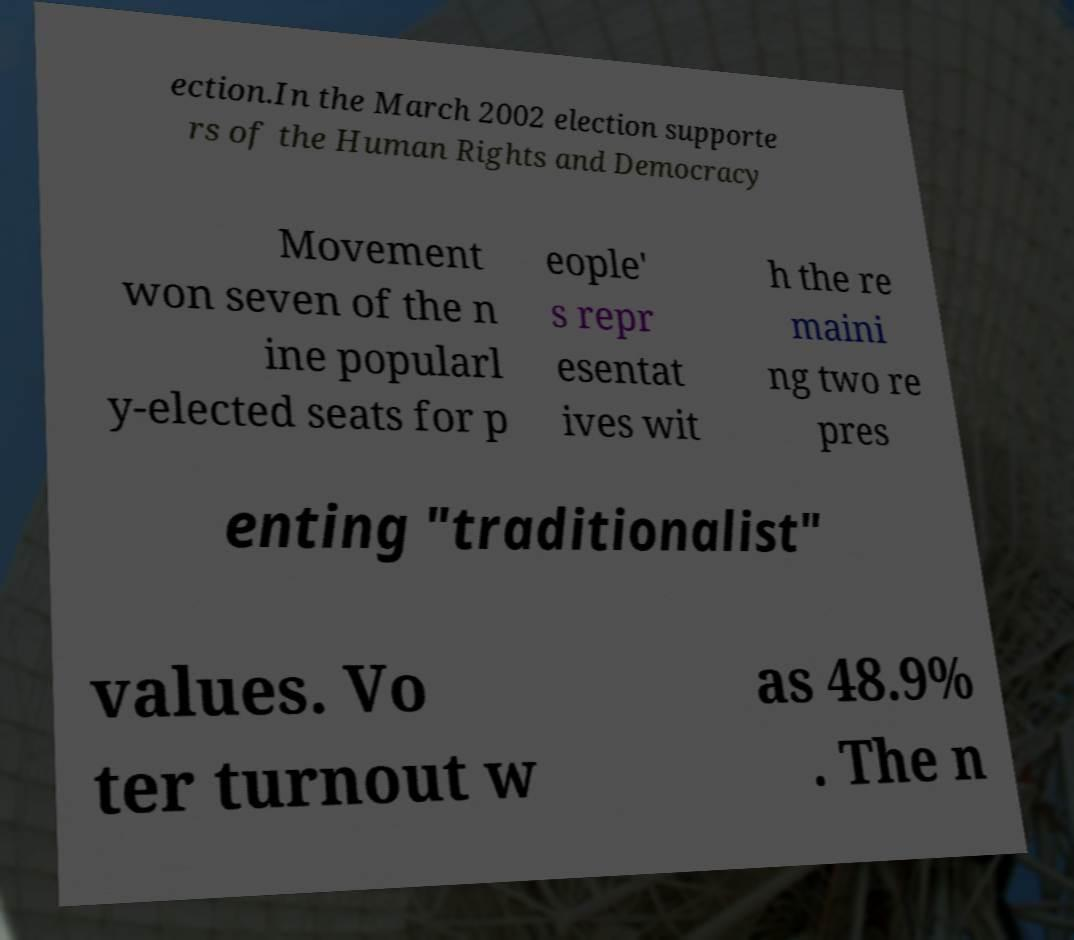Can you accurately transcribe the text from the provided image for me? ection.In the March 2002 election supporte rs of the Human Rights and Democracy Movement won seven of the n ine popularl y-elected seats for p eople' s repr esentat ives wit h the re maini ng two re pres enting "traditionalist" values. Vo ter turnout w as 48.9% . The n 